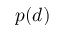<formula> <loc_0><loc_0><loc_500><loc_500>p ( d )</formula> 